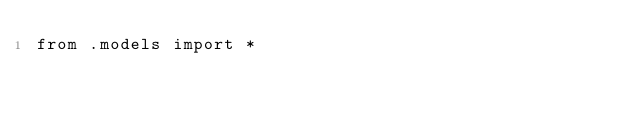<code> <loc_0><loc_0><loc_500><loc_500><_Python_>from .models import *
</code> 